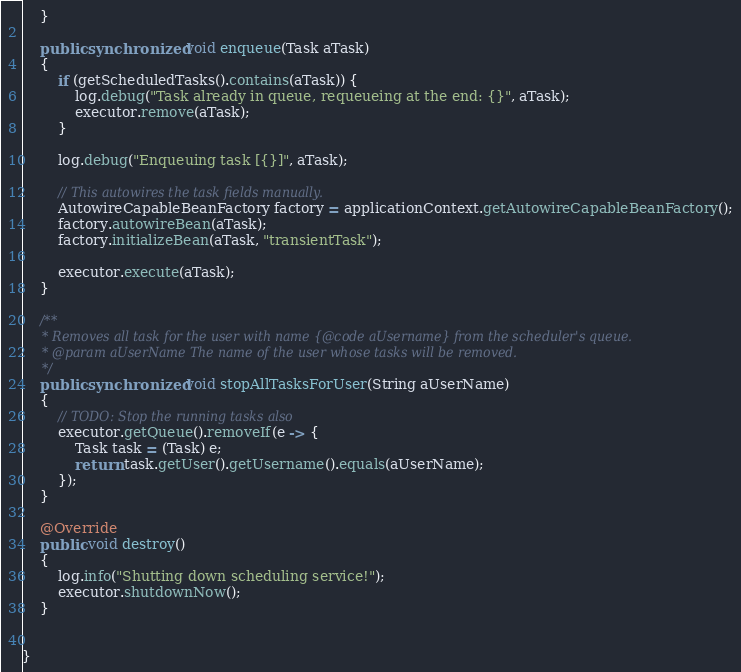<code> <loc_0><loc_0><loc_500><loc_500><_Java_>    }

    public synchronized void enqueue(Task aTask)
    {
        if (getScheduledTasks().contains(aTask)) {
            log.debug("Task already in queue, requeueing at the end: {}", aTask);
            executor.remove(aTask);
        }

        log.debug("Enqueuing task [{}]", aTask);

        // This autowires the task fields manually.
        AutowireCapableBeanFactory factory = applicationContext.getAutowireCapableBeanFactory();
        factory.autowireBean(aTask);
        factory.initializeBean(aTask, "transientTask");

        executor.execute(aTask);
    }

    /**
     * Removes all task for the user with name {@code aUsername} from the scheduler's queue.
     * @param aUserName The name of the user whose tasks will be removed.
     */
    public synchronized void stopAllTasksForUser(String aUserName)
    {
        // TODO: Stop the running tasks also
        executor.getQueue().removeIf(e -> {
            Task task = (Task) e;
            return task.getUser().getUsername().equals(aUserName);
        });
    }

    @Override
    public void destroy()
    {
        log.info("Shutting down scheduling service!");
        executor.shutdownNow();
    }


}
</code> 